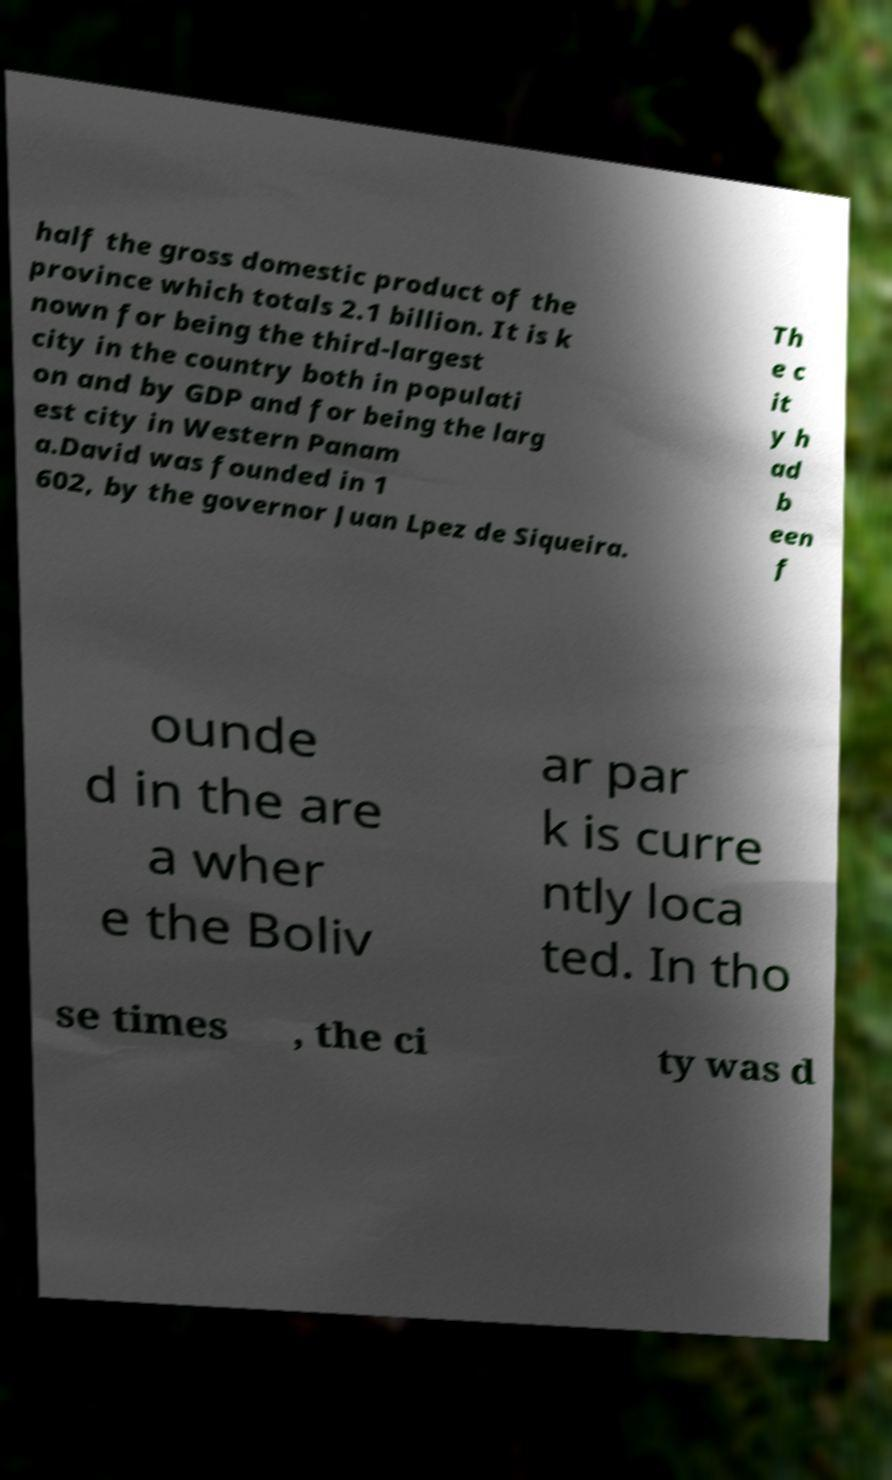What messages or text are displayed in this image? I need them in a readable, typed format. half the gross domestic product of the province which totals 2.1 billion. It is k nown for being the third-largest city in the country both in populati on and by GDP and for being the larg est city in Western Panam a.David was founded in 1 602, by the governor Juan Lpez de Siqueira. Th e c it y h ad b een f ounde d in the are a wher e the Boliv ar par k is curre ntly loca ted. In tho se times , the ci ty was d 